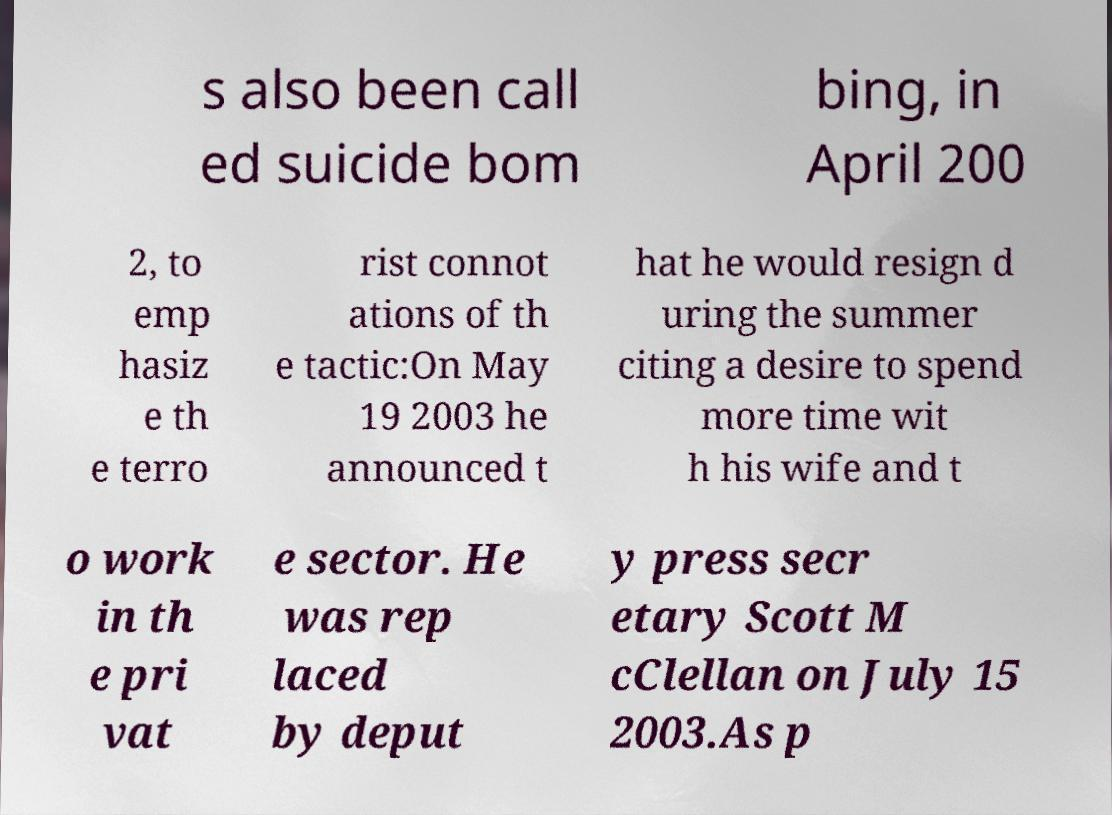Can you accurately transcribe the text from the provided image for me? s also been call ed suicide bom bing, in April 200 2, to emp hasiz e th e terro rist connot ations of th e tactic:On May 19 2003 he announced t hat he would resign d uring the summer citing a desire to spend more time wit h his wife and t o work in th e pri vat e sector. He was rep laced by deput y press secr etary Scott M cClellan on July 15 2003.As p 